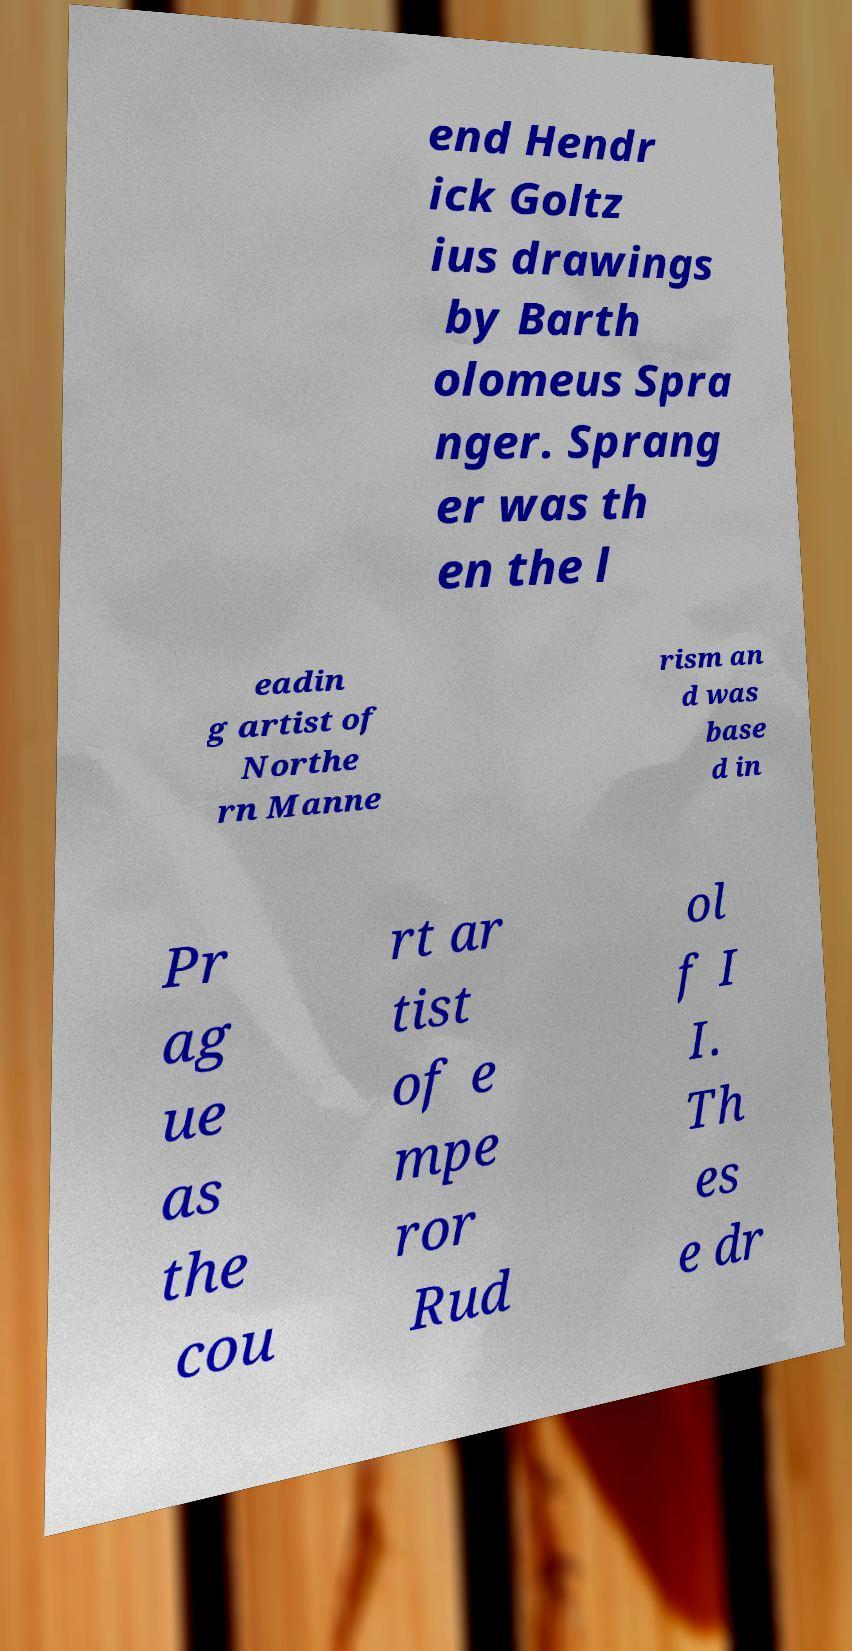Can you accurately transcribe the text from the provided image for me? end Hendr ick Goltz ius drawings by Barth olomeus Spra nger. Sprang er was th en the l eadin g artist of Northe rn Manne rism an d was base d in Pr ag ue as the cou rt ar tist of e mpe ror Rud ol f I I. Th es e dr 